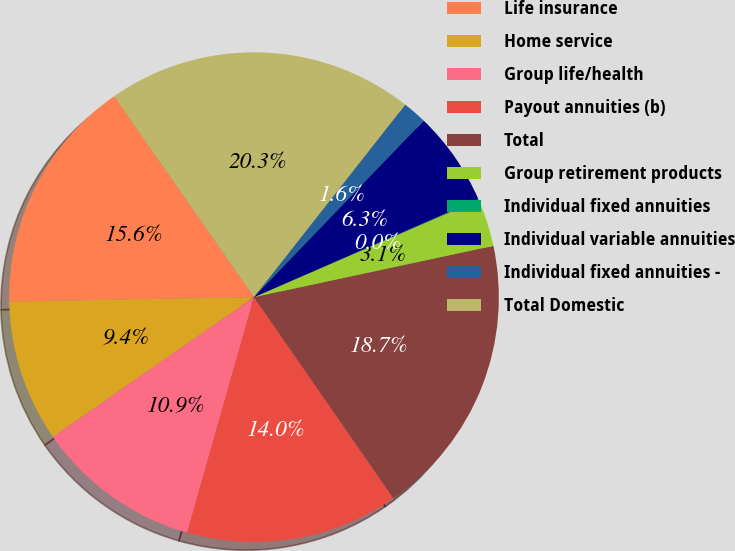Convert chart to OTSL. <chart><loc_0><loc_0><loc_500><loc_500><pie_chart><fcel>Life insurance<fcel>Home service<fcel>Group life/health<fcel>Payout annuities (b)<fcel>Total<fcel>Group retirement products<fcel>Individual fixed annuities<fcel>Individual variable annuities<fcel>Individual fixed annuities -<fcel>Total Domestic<nl><fcel>15.61%<fcel>9.38%<fcel>10.93%<fcel>14.05%<fcel>18.72%<fcel>3.15%<fcel>0.04%<fcel>6.26%<fcel>1.59%<fcel>20.28%<nl></chart> 